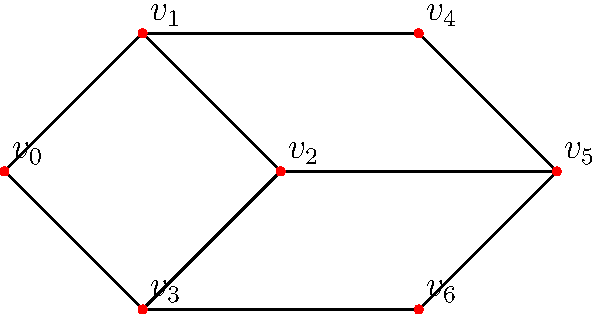The graph represents immigrant communities in different states, where vertices are states and edges indicate significant migration patterns between states. What is the minimum number of states (vertices) that need to be removed to disconnect the graph into two or more components? To solve this problem, we need to find the vertex connectivity of the graph. Let's approach this step-by-step:

1. First, observe that the graph is connected, meaning there's a path between any two vertices.

2. We need to find the minimum number of vertices whose removal will disconnect the graph.

3. Let's examine potential cut-sets:
   - Removing $v_1$ and $v_2$ disconnects $v_0$ from the rest of the graph.
   - Removing $v_1$ and $v_3$ also disconnects $v_0$ from the rest of the graph.
   - Removing $v_2$ and $v_3$ disconnects $v_0$ from the rest of the graph.

4. We can't disconnect the graph by removing only one vertex. For example:
   - Removing $v_1$ leaves a path through $v_2$ and $v_3$.
   - Removing $v_2$ leaves a path through $v_1$ and $v_3$.
   - Removing $v_3$ leaves a path through $v_1$ and $v_2$.

5. Therefore, the minimum number of vertices that need to be removed to disconnect the graph is 2.

This number is known as the vertex connectivity of the graph.
Answer: 2 